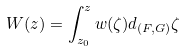<formula> <loc_0><loc_0><loc_500><loc_500>W ( z ) = \int _ { z _ { 0 } } ^ { z } w ( \zeta ) d _ { ( F , G ) } \zeta</formula> 